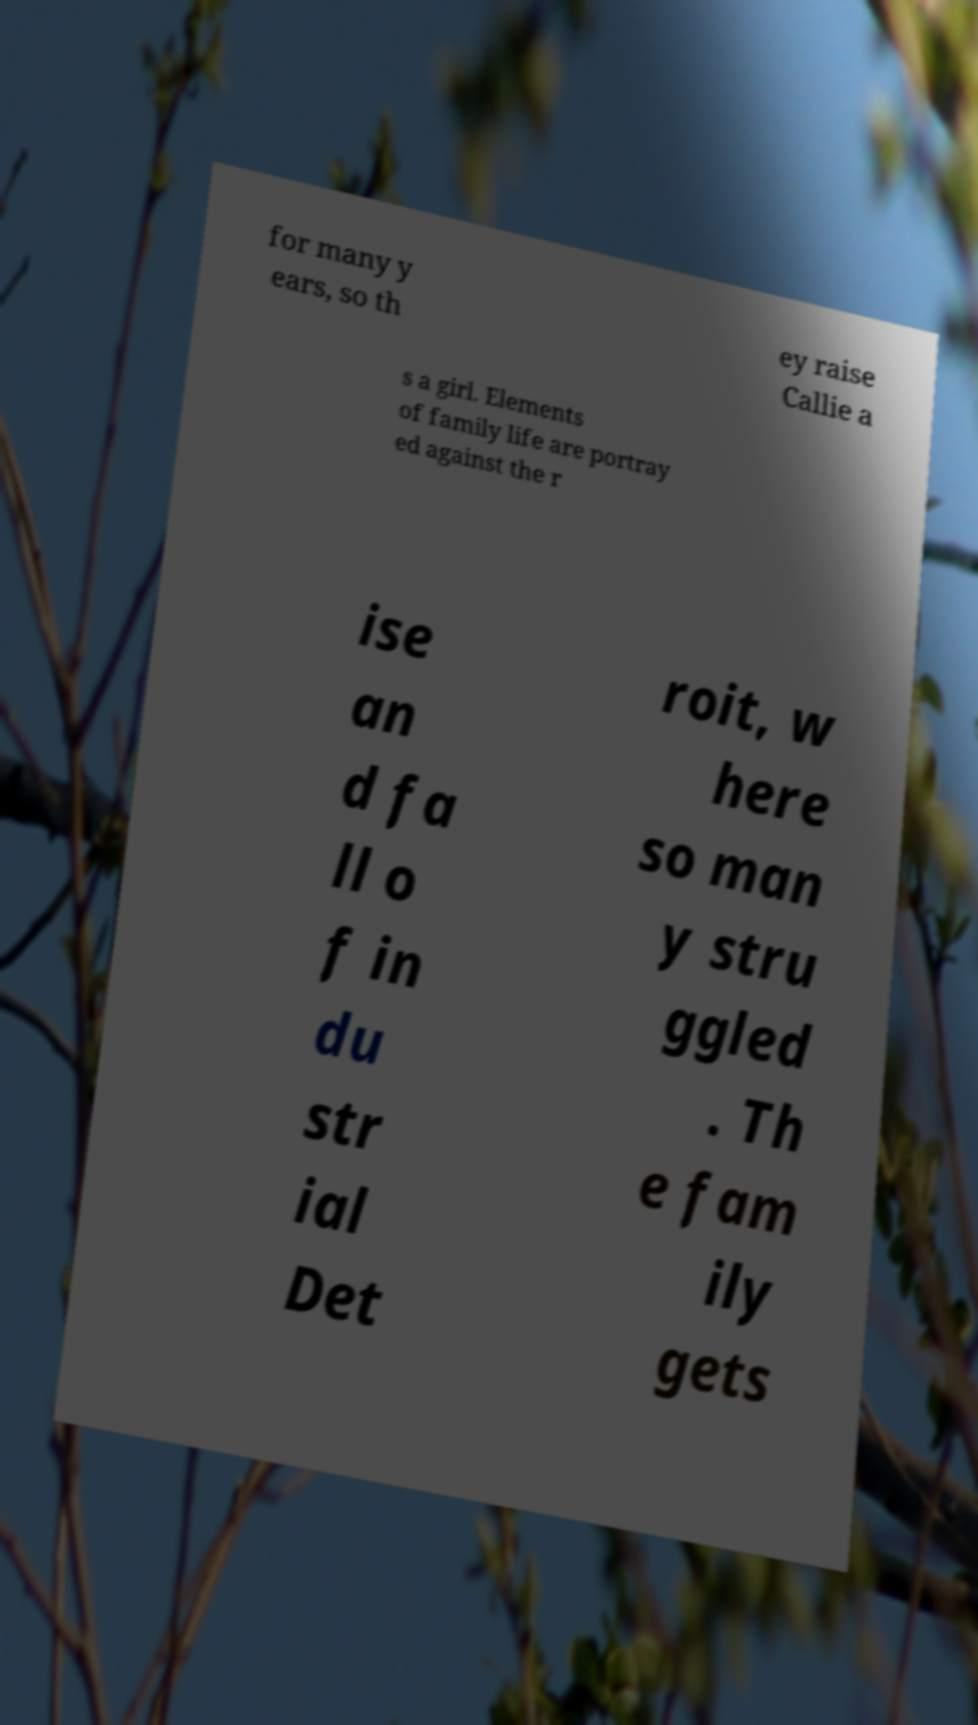Could you assist in decoding the text presented in this image and type it out clearly? for many y ears, so th ey raise Callie a s a girl. Elements of family life are portray ed against the r ise an d fa ll o f in du str ial Det roit, w here so man y stru ggled . Th e fam ily gets 